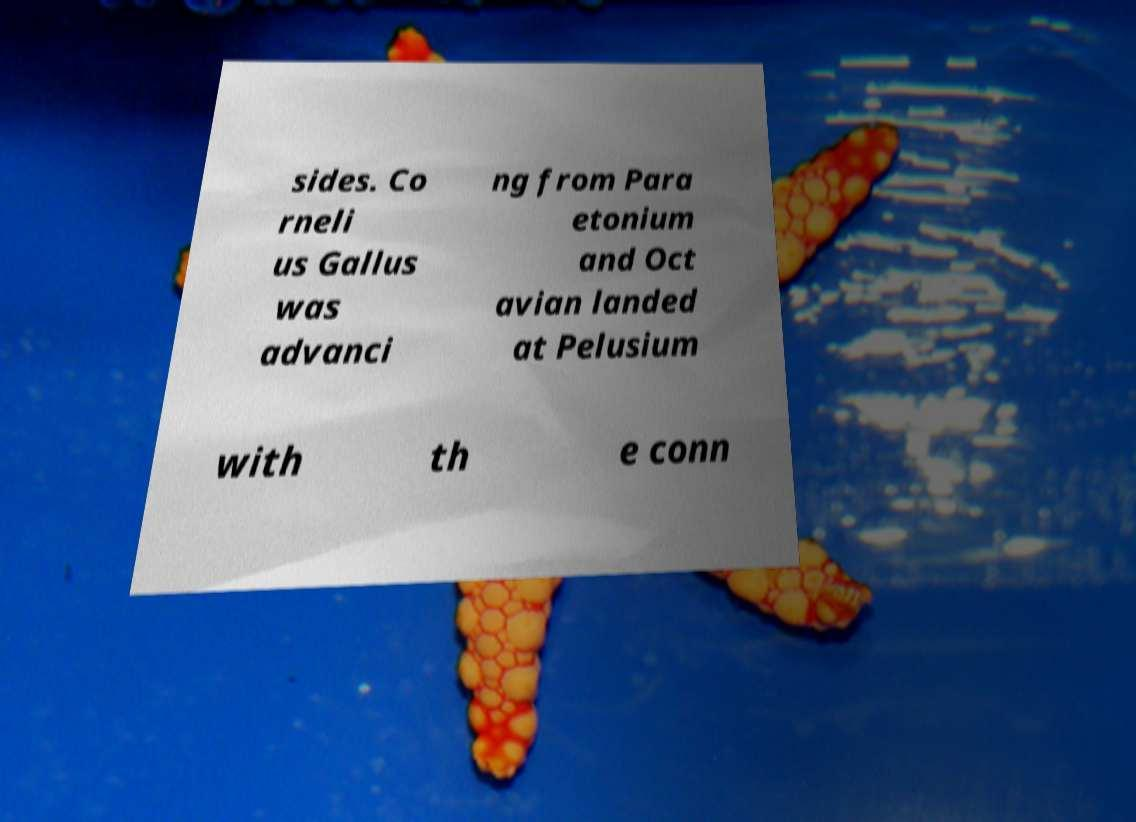I need the written content from this picture converted into text. Can you do that? sides. Co rneli us Gallus was advanci ng from Para etonium and Oct avian landed at Pelusium with th e conn 